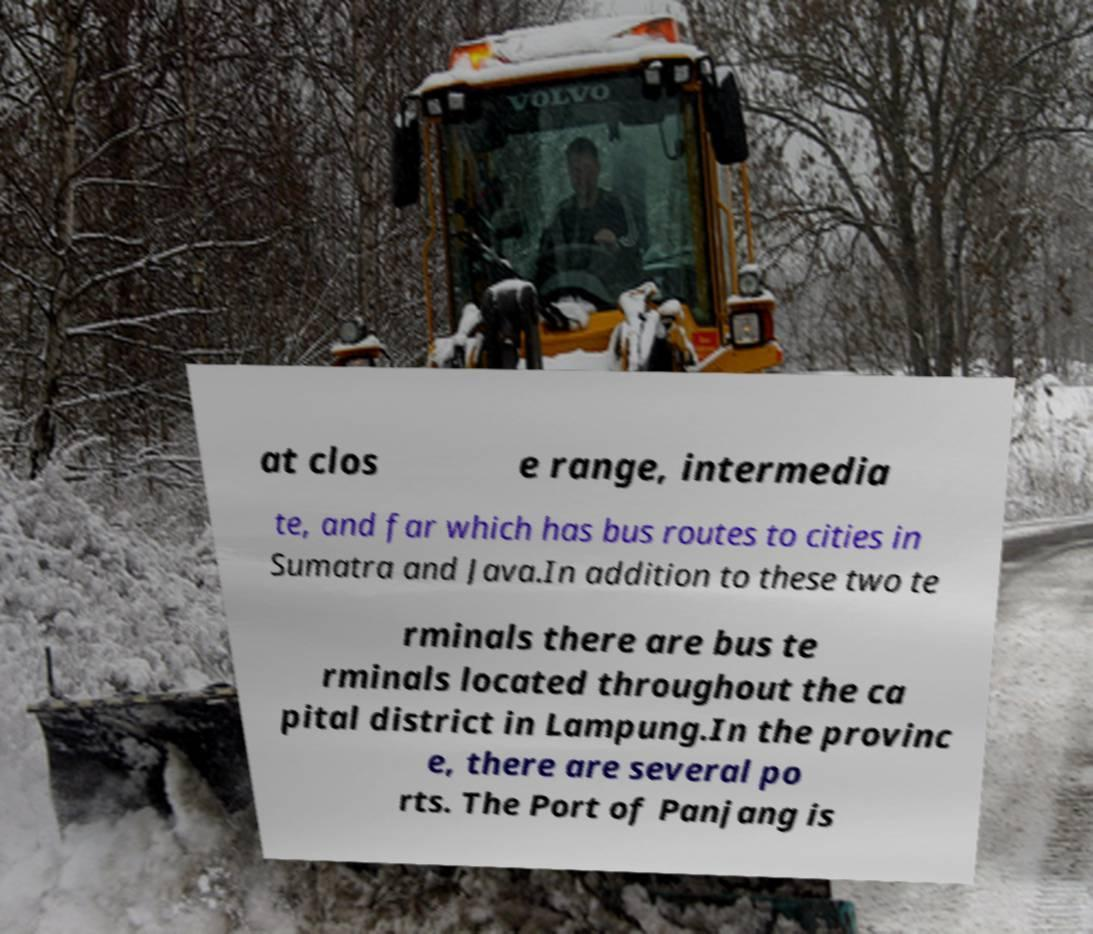For documentation purposes, I need the text within this image transcribed. Could you provide that? at clos e range, intermedia te, and far which has bus routes to cities in Sumatra and Java.In addition to these two te rminals there are bus te rminals located throughout the ca pital district in Lampung.In the provinc e, there are several po rts. The Port of Panjang is 